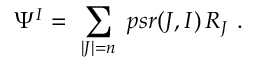<formula> <loc_0><loc_0><loc_500><loc_500>\Psi ^ { I } = \ \sum _ { | J | = n } \ p s r ( J , I ) \, R _ { J } \ .</formula> 